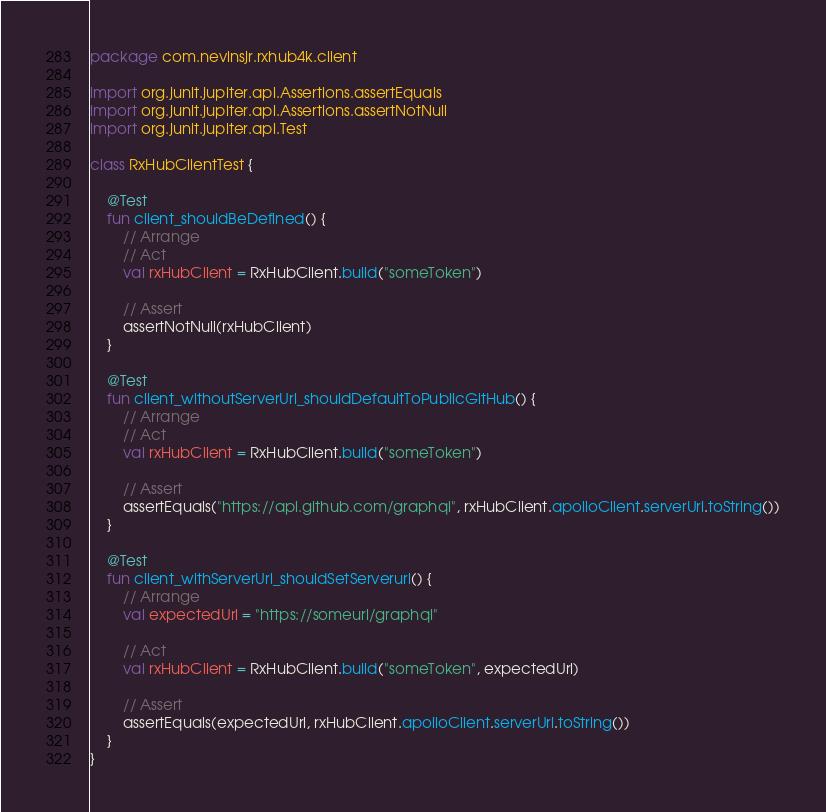<code> <loc_0><loc_0><loc_500><loc_500><_Kotlin_>package com.nevinsjr.rxhub4k.client

import org.junit.jupiter.api.Assertions.assertEquals
import org.junit.jupiter.api.Assertions.assertNotNull
import org.junit.jupiter.api.Test

class RxHubClientTest {

    @Test
    fun client_shouldBeDefined() {
        // Arrange
        // Act
        val rxHubClient = RxHubClient.build("someToken")

        // Assert
        assertNotNull(rxHubClient)
    }

    @Test
    fun client_withoutServerUrl_shouldDefaultToPublicGitHub() {
        // Arrange
        // Act
        val rxHubClient = RxHubClient.build("someToken")

        // Assert
        assertEquals("https://api.github.com/graphql", rxHubClient.apolloClient.serverUrl.toString())
    }

    @Test
    fun client_withServerUrl_shouldSetServerurl() {
        // Arrange
        val expectedUrl = "https://someurl/graphql"

        // Act
        val rxHubClient = RxHubClient.build("someToken", expectedUrl)

        // Assert
        assertEquals(expectedUrl, rxHubClient.apolloClient.serverUrl.toString())
    }
}
</code> 